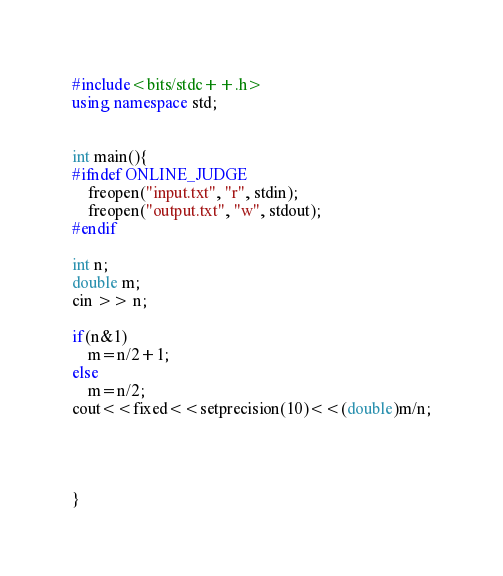Convert code to text. <code><loc_0><loc_0><loc_500><loc_500><_C++_>#include<bits/stdc++.h>
using namespace std; 


int main(){
#ifndef ONLINE_JUDGE
    freopen("input.txt", "r", stdin);
    freopen("output.txt", "w", stdout);
#endif

int n;
double m;  
cin >> n;

if(n&1)
	m=n/2+1;
else 
	m=n/2; 
cout<<fixed<<setprecision(10)<<(double)m/n;




}
</code> 